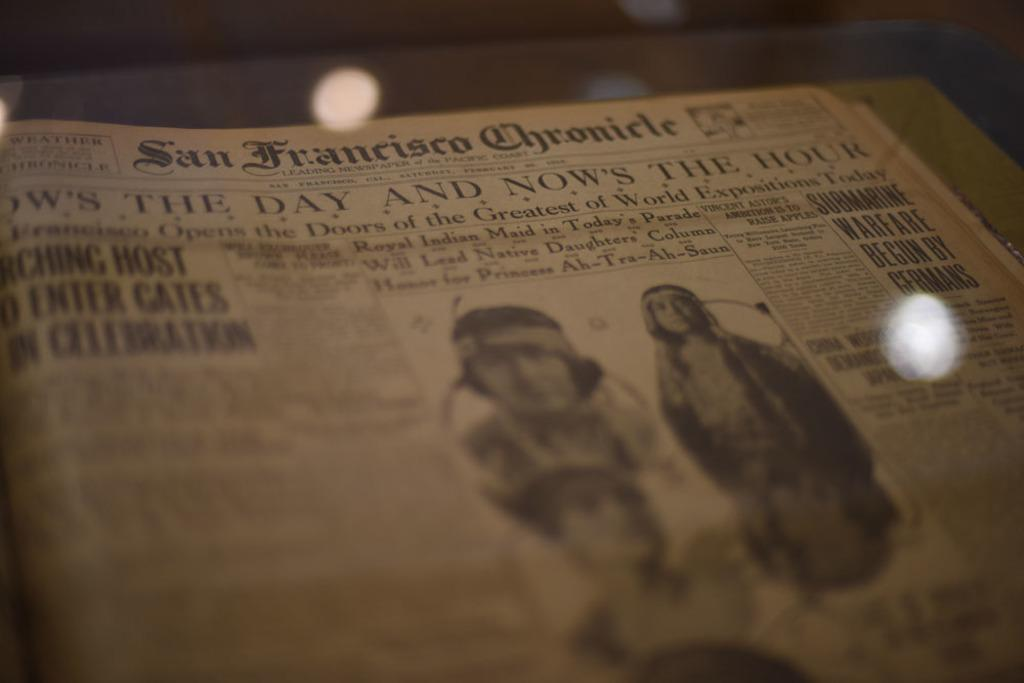What is the main object in the image? There is a newspaper in the image. What can be found on the newspaper? There is writing and a picture of people on the newspaper. How would you describe the background of the image? The background of the image is black and blurry. What type of mist can be seen surrounding the people in the picture on the newspaper? There is no mist present in the image, as it features a newspaper with writing and a picture of people. 